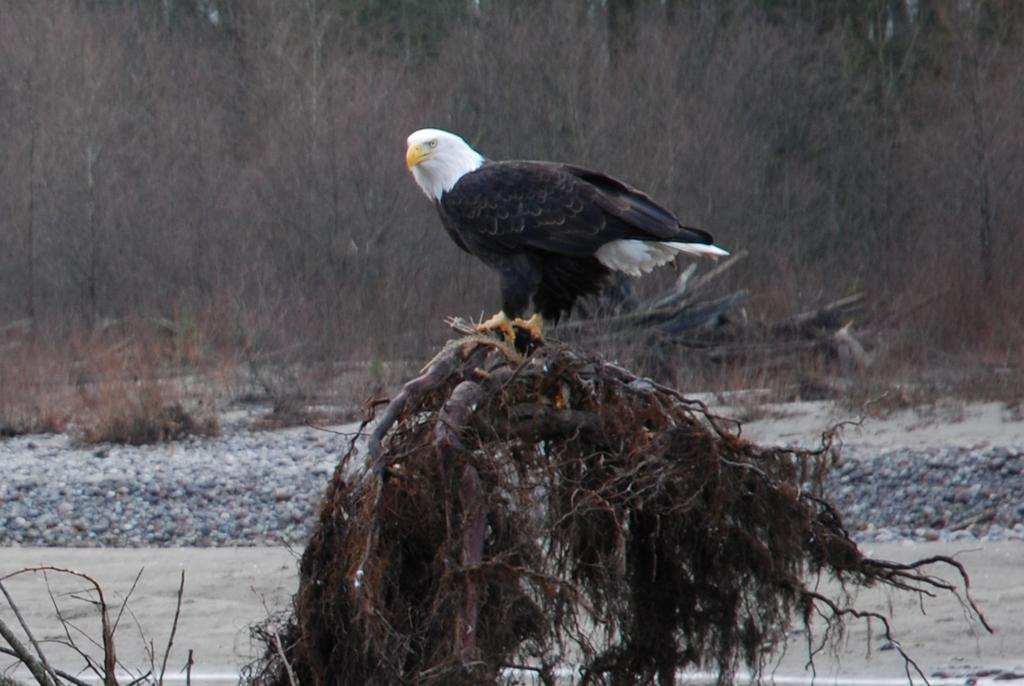In one or two sentences, can you explain what this image depicts? In this picture we can observe an eagle which is in white and black color, standing on the branch of a tree. We can observe water. In the background there are some dried plants and trees. 